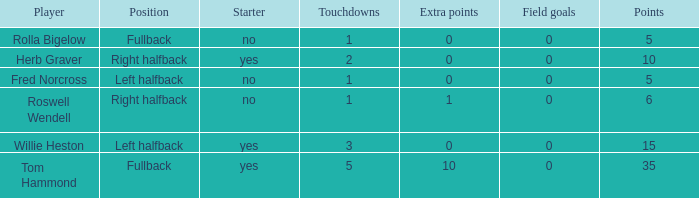How many extra points did right halfback Roswell Wendell have? 1.0. 